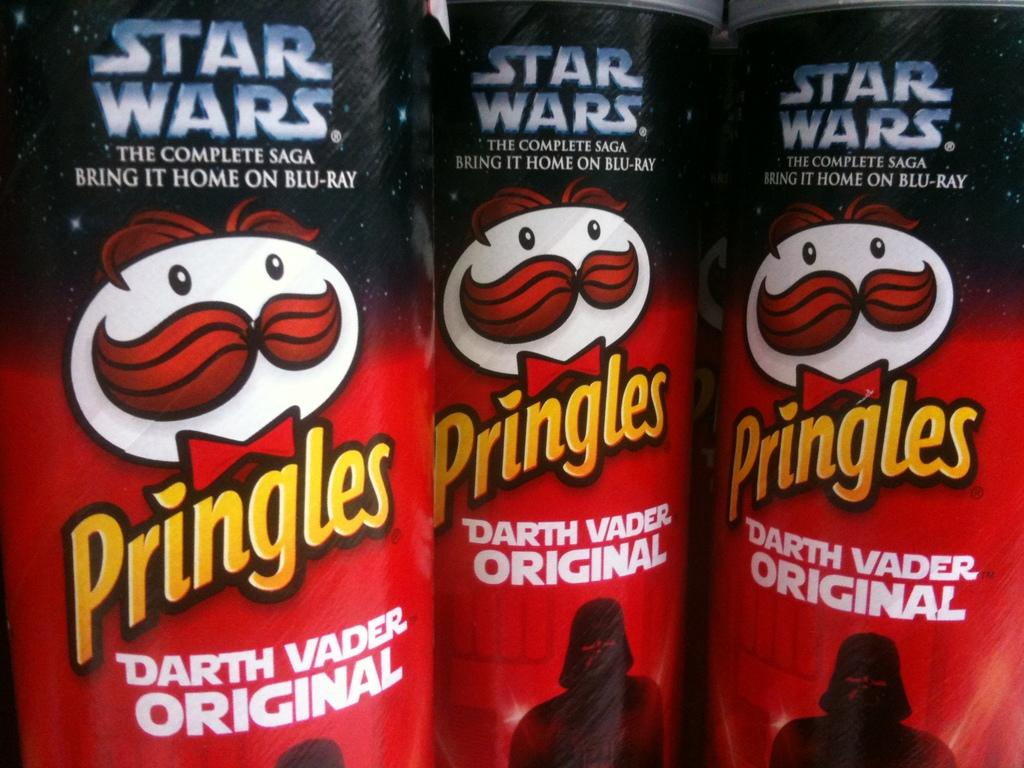<image>
Render a clear and concise summary of the photo. Several cans of Star Wars pringles are placed together. 